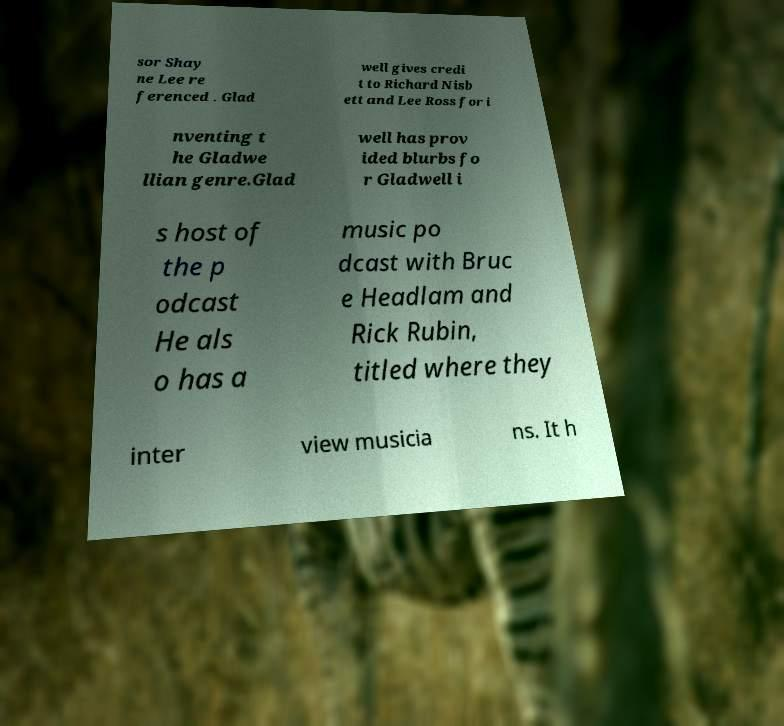Can you read and provide the text displayed in the image?This photo seems to have some interesting text. Can you extract and type it out for me? sor Shay ne Lee re ferenced . Glad well gives credi t to Richard Nisb ett and Lee Ross for i nventing t he Gladwe llian genre.Glad well has prov ided blurbs fo r Gladwell i s host of the p odcast He als o has a music po dcast with Bruc e Headlam and Rick Rubin, titled where they inter view musicia ns. It h 